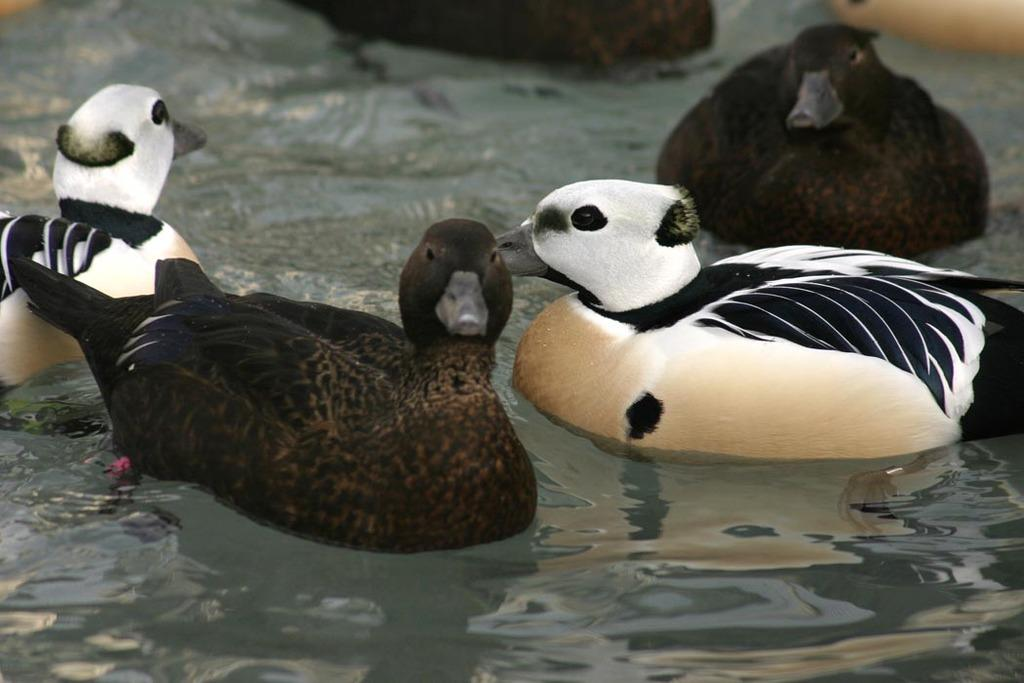What type of animals are in the water in the image? There are ducks in the water in the image. How many ducks are present in the image? There are four ducks in the image. What colors can be seen on the ducks? The ducks have white and black colors. What is the crowd's reaction to the lizards in the image? There are no lizards or crowds present in the image; it features ducks in the water. 